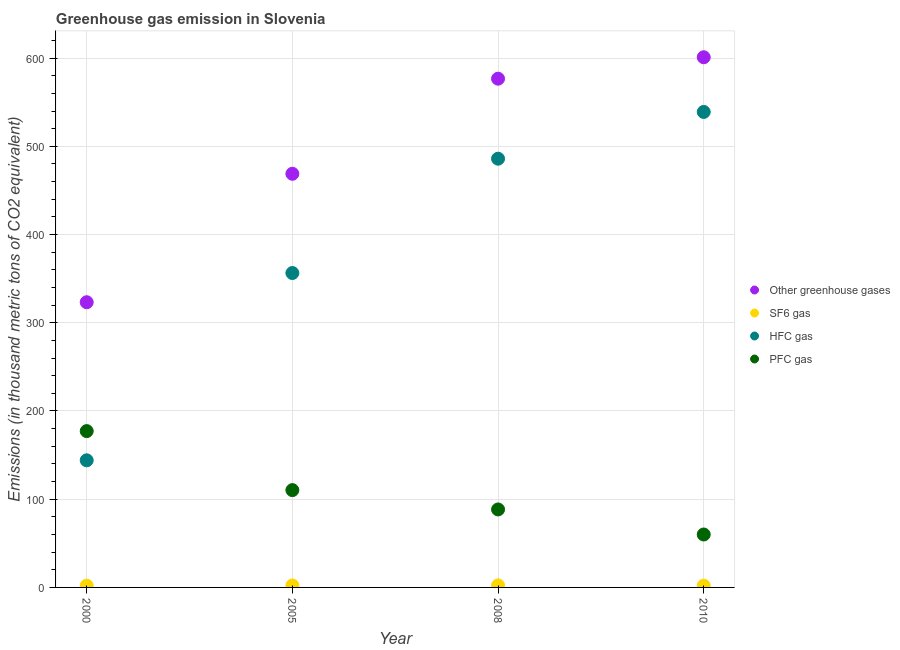What is the emission of pfc gas in 2008?
Your answer should be compact. 88.4. Across all years, what is the maximum emission of pfc gas?
Your answer should be very brief. 177.2. Across all years, what is the minimum emission of pfc gas?
Keep it short and to the point. 60. In which year was the emission of greenhouse gases minimum?
Provide a succinct answer. 2000. What is the total emission of sf6 gas in the graph?
Provide a succinct answer. 8.5. What is the difference between the emission of greenhouse gases in 2000 and that in 2008?
Your answer should be compact. -253.4. What is the difference between the emission of greenhouse gases in 2010 and the emission of hfc gas in 2005?
Ensure brevity in your answer.  244.6. What is the average emission of sf6 gas per year?
Your response must be concise. 2.12. In the year 2008, what is the difference between the emission of hfc gas and emission of sf6 gas?
Give a very brief answer. 483.7. What is the ratio of the emission of sf6 gas in 2005 to that in 2010?
Provide a short and direct response. 1.1. Is the emission of hfc gas in 2000 less than that in 2005?
Offer a very short reply. Yes. Is the difference between the emission of greenhouse gases in 2000 and 2010 greater than the difference between the emission of pfc gas in 2000 and 2010?
Provide a succinct answer. No. What is the difference between the highest and the second highest emission of sf6 gas?
Your answer should be compact. 0.1. What is the difference between the highest and the lowest emission of greenhouse gases?
Your answer should be very brief. 277.7. In how many years, is the emission of pfc gas greater than the average emission of pfc gas taken over all years?
Offer a terse response. 2. Is it the case that in every year, the sum of the emission of greenhouse gases and emission of sf6 gas is greater than the emission of hfc gas?
Make the answer very short. Yes. Is the emission of sf6 gas strictly greater than the emission of greenhouse gases over the years?
Keep it short and to the point. No. Is the emission of greenhouse gases strictly less than the emission of pfc gas over the years?
Your answer should be compact. No. What is the difference between two consecutive major ticks on the Y-axis?
Your response must be concise. 100. Does the graph contain any zero values?
Offer a terse response. No. Does the graph contain grids?
Give a very brief answer. Yes. What is the title of the graph?
Your answer should be compact. Greenhouse gas emission in Slovenia. What is the label or title of the Y-axis?
Your answer should be very brief. Emissions (in thousand metric tons of CO2 equivalent). What is the Emissions (in thousand metric tons of CO2 equivalent) in Other greenhouse gases in 2000?
Provide a succinct answer. 323.3. What is the Emissions (in thousand metric tons of CO2 equivalent) of SF6 gas in 2000?
Give a very brief answer. 2. What is the Emissions (in thousand metric tons of CO2 equivalent) of HFC gas in 2000?
Offer a very short reply. 144.1. What is the Emissions (in thousand metric tons of CO2 equivalent) in PFC gas in 2000?
Ensure brevity in your answer.  177.2. What is the Emissions (in thousand metric tons of CO2 equivalent) in Other greenhouse gases in 2005?
Offer a terse response. 468.9. What is the Emissions (in thousand metric tons of CO2 equivalent) of SF6 gas in 2005?
Provide a short and direct response. 2.2. What is the Emissions (in thousand metric tons of CO2 equivalent) of HFC gas in 2005?
Your response must be concise. 356.4. What is the Emissions (in thousand metric tons of CO2 equivalent) in PFC gas in 2005?
Your response must be concise. 110.3. What is the Emissions (in thousand metric tons of CO2 equivalent) in Other greenhouse gases in 2008?
Offer a very short reply. 576.7. What is the Emissions (in thousand metric tons of CO2 equivalent) of HFC gas in 2008?
Make the answer very short. 486. What is the Emissions (in thousand metric tons of CO2 equivalent) in PFC gas in 2008?
Make the answer very short. 88.4. What is the Emissions (in thousand metric tons of CO2 equivalent) in Other greenhouse gases in 2010?
Provide a short and direct response. 601. What is the Emissions (in thousand metric tons of CO2 equivalent) of SF6 gas in 2010?
Your answer should be compact. 2. What is the Emissions (in thousand metric tons of CO2 equivalent) of HFC gas in 2010?
Your answer should be very brief. 539. What is the Emissions (in thousand metric tons of CO2 equivalent) of PFC gas in 2010?
Provide a short and direct response. 60. Across all years, what is the maximum Emissions (in thousand metric tons of CO2 equivalent) of Other greenhouse gases?
Your answer should be very brief. 601. Across all years, what is the maximum Emissions (in thousand metric tons of CO2 equivalent) in HFC gas?
Your answer should be very brief. 539. Across all years, what is the maximum Emissions (in thousand metric tons of CO2 equivalent) in PFC gas?
Provide a succinct answer. 177.2. Across all years, what is the minimum Emissions (in thousand metric tons of CO2 equivalent) in Other greenhouse gases?
Make the answer very short. 323.3. Across all years, what is the minimum Emissions (in thousand metric tons of CO2 equivalent) in HFC gas?
Provide a short and direct response. 144.1. Across all years, what is the minimum Emissions (in thousand metric tons of CO2 equivalent) in PFC gas?
Give a very brief answer. 60. What is the total Emissions (in thousand metric tons of CO2 equivalent) in Other greenhouse gases in the graph?
Your response must be concise. 1969.9. What is the total Emissions (in thousand metric tons of CO2 equivalent) of SF6 gas in the graph?
Your answer should be compact. 8.5. What is the total Emissions (in thousand metric tons of CO2 equivalent) in HFC gas in the graph?
Your answer should be compact. 1525.5. What is the total Emissions (in thousand metric tons of CO2 equivalent) of PFC gas in the graph?
Ensure brevity in your answer.  435.9. What is the difference between the Emissions (in thousand metric tons of CO2 equivalent) of Other greenhouse gases in 2000 and that in 2005?
Your answer should be compact. -145.6. What is the difference between the Emissions (in thousand metric tons of CO2 equivalent) in HFC gas in 2000 and that in 2005?
Offer a terse response. -212.3. What is the difference between the Emissions (in thousand metric tons of CO2 equivalent) of PFC gas in 2000 and that in 2005?
Offer a very short reply. 66.9. What is the difference between the Emissions (in thousand metric tons of CO2 equivalent) of Other greenhouse gases in 2000 and that in 2008?
Ensure brevity in your answer.  -253.4. What is the difference between the Emissions (in thousand metric tons of CO2 equivalent) in HFC gas in 2000 and that in 2008?
Give a very brief answer. -341.9. What is the difference between the Emissions (in thousand metric tons of CO2 equivalent) of PFC gas in 2000 and that in 2008?
Provide a short and direct response. 88.8. What is the difference between the Emissions (in thousand metric tons of CO2 equivalent) in Other greenhouse gases in 2000 and that in 2010?
Give a very brief answer. -277.7. What is the difference between the Emissions (in thousand metric tons of CO2 equivalent) in SF6 gas in 2000 and that in 2010?
Provide a succinct answer. 0. What is the difference between the Emissions (in thousand metric tons of CO2 equivalent) in HFC gas in 2000 and that in 2010?
Give a very brief answer. -394.9. What is the difference between the Emissions (in thousand metric tons of CO2 equivalent) in PFC gas in 2000 and that in 2010?
Make the answer very short. 117.2. What is the difference between the Emissions (in thousand metric tons of CO2 equivalent) in Other greenhouse gases in 2005 and that in 2008?
Make the answer very short. -107.8. What is the difference between the Emissions (in thousand metric tons of CO2 equivalent) of HFC gas in 2005 and that in 2008?
Provide a succinct answer. -129.6. What is the difference between the Emissions (in thousand metric tons of CO2 equivalent) of PFC gas in 2005 and that in 2008?
Keep it short and to the point. 21.9. What is the difference between the Emissions (in thousand metric tons of CO2 equivalent) in Other greenhouse gases in 2005 and that in 2010?
Make the answer very short. -132.1. What is the difference between the Emissions (in thousand metric tons of CO2 equivalent) of HFC gas in 2005 and that in 2010?
Provide a short and direct response. -182.6. What is the difference between the Emissions (in thousand metric tons of CO2 equivalent) in PFC gas in 2005 and that in 2010?
Provide a succinct answer. 50.3. What is the difference between the Emissions (in thousand metric tons of CO2 equivalent) in Other greenhouse gases in 2008 and that in 2010?
Keep it short and to the point. -24.3. What is the difference between the Emissions (in thousand metric tons of CO2 equivalent) in SF6 gas in 2008 and that in 2010?
Your answer should be compact. 0.3. What is the difference between the Emissions (in thousand metric tons of CO2 equivalent) of HFC gas in 2008 and that in 2010?
Your response must be concise. -53. What is the difference between the Emissions (in thousand metric tons of CO2 equivalent) of PFC gas in 2008 and that in 2010?
Offer a very short reply. 28.4. What is the difference between the Emissions (in thousand metric tons of CO2 equivalent) in Other greenhouse gases in 2000 and the Emissions (in thousand metric tons of CO2 equivalent) in SF6 gas in 2005?
Offer a terse response. 321.1. What is the difference between the Emissions (in thousand metric tons of CO2 equivalent) in Other greenhouse gases in 2000 and the Emissions (in thousand metric tons of CO2 equivalent) in HFC gas in 2005?
Your answer should be very brief. -33.1. What is the difference between the Emissions (in thousand metric tons of CO2 equivalent) in Other greenhouse gases in 2000 and the Emissions (in thousand metric tons of CO2 equivalent) in PFC gas in 2005?
Provide a succinct answer. 213. What is the difference between the Emissions (in thousand metric tons of CO2 equivalent) in SF6 gas in 2000 and the Emissions (in thousand metric tons of CO2 equivalent) in HFC gas in 2005?
Ensure brevity in your answer.  -354.4. What is the difference between the Emissions (in thousand metric tons of CO2 equivalent) in SF6 gas in 2000 and the Emissions (in thousand metric tons of CO2 equivalent) in PFC gas in 2005?
Make the answer very short. -108.3. What is the difference between the Emissions (in thousand metric tons of CO2 equivalent) of HFC gas in 2000 and the Emissions (in thousand metric tons of CO2 equivalent) of PFC gas in 2005?
Give a very brief answer. 33.8. What is the difference between the Emissions (in thousand metric tons of CO2 equivalent) of Other greenhouse gases in 2000 and the Emissions (in thousand metric tons of CO2 equivalent) of SF6 gas in 2008?
Your answer should be very brief. 321. What is the difference between the Emissions (in thousand metric tons of CO2 equivalent) in Other greenhouse gases in 2000 and the Emissions (in thousand metric tons of CO2 equivalent) in HFC gas in 2008?
Offer a very short reply. -162.7. What is the difference between the Emissions (in thousand metric tons of CO2 equivalent) in Other greenhouse gases in 2000 and the Emissions (in thousand metric tons of CO2 equivalent) in PFC gas in 2008?
Give a very brief answer. 234.9. What is the difference between the Emissions (in thousand metric tons of CO2 equivalent) in SF6 gas in 2000 and the Emissions (in thousand metric tons of CO2 equivalent) in HFC gas in 2008?
Your answer should be very brief. -484. What is the difference between the Emissions (in thousand metric tons of CO2 equivalent) in SF6 gas in 2000 and the Emissions (in thousand metric tons of CO2 equivalent) in PFC gas in 2008?
Offer a terse response. -86.4. What is the difference between the Emissions (in thousand metric tons of CO2 equivalent) in HFC gas in 2000 and the Emissions (in thousand metric tons of CO2 equivalent) in PFC gas in 2008?
Your response must be concise. 55.7. What is the difference between the Emissions (in thousand metric tons of CO2 equivalent) in Other greenhouse gases in 2000 and the Emissions (in thousand metric tons of CO2 equivalent) in SF6 gas in 2010?
Make the answer very short. 321.3. What is the difference between the Emissions (in thousand metric tons of CO2 equivalent) in Other greenhouse gases in 2000 and the Emissions (in thousand metric tons of CO2 equivalent) in HFC gas in 2010?
Provide a short and direct response. -215.7. What is the difference between the Emissions (in thousand metric tons of CO2 equivalent) in Other greenhouse gases in 2000 and the Emissions (in thousand metric tons of CO2 equivalent) in PFC gas in 2010?
Provide a short and direct response. 263.3. What is the difference between the Emissions (in thousand metric tons of CO2 equivalent) of SF6 gas in 2000 and the Emissions (in thousand metric tons of CO2 equivalent) of HFC gas in 2010?
Offer a terse response. -537. What is the difference between the Emissions (in thousand metric tons of CO2 equivalent) of SF6 gas in 2000 and the Emissions (in thousand metric tons of CO2 equivalent) of PFC gas in 2010?
Your response must be concise. -58. What is the difference between the Emissions (in thousand metric tons of CO2 equivalent) in HFC gas in 2000 and the Emissions (in thousand metric tons of CO2 equivalent) in PFC gas in 2010?
Make the answer very short. 84.1. What is the difference between the Emissions (in thousand metric tons of CO2 equivalent) of Other greenhouse gases in 2005 and the Emissions (in thousand metric tons of CO2 equivalent) of SF6 gas in 2008?
Your answer should be very brief. 466.6. What is the difference between the Emissions (in thousand metric tons of CO2 equivalent) of Other greenhouse gases in 2005 and the Emissions (in thousand metric tons of CO2 equivalent) of HFC gas in 2008?
Make the answer very short. -17.1. What is the difference between the Emissions (in thousand metric tons of CO2 equivalent) of Other greenhouse gases in 2005 and the Emissions (in thousand metric tons of CO2 equivalent) of PFC gas in 2008?
Ensure brevity in your answer.  380.5. What is the difference between the Emissions (in thousand metric tons of CO2 equivalent) in SF6 gas in 2005 and the Emissions (in thousand metric tons of CO2 equivalent) in HFC gas in 2008?
Provide a succinct answer. -483.8. What is the difference between the Emissions (in thousand metric tons of CO2 equivalent) in SF6 gas in 2005 and the Emissions (in thousand metric tons of CO2 equivalent) in PFC gas in 2008?
Your answer should be compact. -86.2. What is the difference between the Emissions (in thousand metric tons of CO2 equivalent) in HFC gas in 2005 and the Emissions (in thousand metric tons of CO2 equivalent) in PFC gas in 2008?
Give a very brief answer. 268. What is the difference between the Emissions (in thousand metric tons of CO2 equivalent) in Other greenhouse gases in 2005 and the Emissions (in thousand metric tons of CO2 equivalent) in SF6 gas in 2010?
Ensure brevity in your answer.  466.9. What is the difference between the Emissions (in thousand metric tons of CO2 equivalent) of Other greenhouse gases in 2005 and the Emissions (in thousand metric tons of CO2 equivalent) of HFC gas in 2010?
Ensure brevity in your answer.  -70.1. What is the difference between the Emissions (in thousand metric tons of CO2 equivalent) in Other greenhouse gases in 2005 and the Emissions (in thousand metric tons of CO2 equivalent) in PFC gas in 2010?
Keep it short and to the point. 408.9. What is the difference between the Emissions (in thousand metric tons of CO2 equivalent) in SF6 gas in 2005 and the Emissions (in thousand metric tons of CO2 equivalent) in HFC gas in 2010?
Ensure brevity in your answer.  -536.8. What is the difference between the Emissions (in thousand metric tons of CO2 equivalent) in SF6 gas in 2005 and the Emissions (in thousand metric tons of CO2 equivalent) in PFC gas in 2010?
Keep it short and to the point. -57.8. What is the difference between the Emissions (in thousand metric tons of CO2 equivalent) in HFC gas in 2005 and the Emissions (in thousand metric tons of CO2 equivalent) in PFC gas in 2010?
Ensure brevity in your answer.  296.4. What is the difference between the Emissions (in thousand metric tons of CO2 equivalent) of Other greenhouse gases in 2008 and the Emissions (in thousand metric tons of CO2 equivalent) of SF6 gas in 2010?
Ensure brevity in your answer.  574.7. What is the difference between the Emissions (in thousand metric tons of CO2 equivalent) of Other greenhouse gases in 2008 and the Emissions (in thousand metric tons of CO2 equivalent) of HFC gas in 2010?
Keep it short and to the point. 37.7. What is the difference between the Emissions (in thousand metric tons of CO2 equivalent) of Other greenhouse gases in 2008 and the Emissions (in thousand metric tons of CO2 equivalent) of PFC gas in 2010?
Provide a short and direct response. 516.7. What is the difference between the Emissions (in thousand metric tons of CO2 equivalent) in SF6 gas in 2008 and the Emissions (in thousand metric tons of CO2 equivalent) in HFC gas in 2010?
Ensure brevity in your answer.  -536.7. What is the difference between the Emissions (in thousand metric tons of CO2 equivalent) of SF6 gas in 2008 and the Emissions (in thousand metric tons of CO2 equivalent) of PFC gas in 2010?
Ensure brevity in your answer.  -57.7. What is the difference between the Emissions (in thousand metric tons of CO2 equivalent) of HFC gas in 2008 and the Emissions (in thousand metric tons of CO2 equivalent) of PFC gas in 2010?
Give a very brief answer. 426. What is the average Emissions (in thousand metric tons of CO2 equivalent) in Other greenhouse gases per year?
Keep it short and to the point. 492.48. What is the average Emissions (in thousand metric tons of CO2 equivalent) in SF6 gas per year?
Offer a very short reply. 2.12. What is the average Emissions (in thousand metric tons of CO2 equivalent) of HFC gas per year?
Your answer should be compact. 381.38. What is the average Emissions (in thousand metric tons of CO2 equivalent) of PFC gas per year?
Keep it short and to the point. 108.97. In the year 2000, what is the difference between the Emissions (in thousand metric tons of CO2 equivalent) of Other greenhouse gases and Emissions (in thousand metric tons of CO2 equivalent) of SF6 gas?
Offer a very short reply. 321.3. In the year 2000, what is the difference between the Emissions (in thousand metric tons of CO2 equivalent) in Other greenhouse gases and Emissions (in thousand metric tons of CO2 equivalent) in HFC gas?
Provide a short and direct response. 179.2. In the year 2000, what is the difference between the Emissions (in thousand metric tons of CO2 equivalent) in Other greenhouse gases and Emissions (in thousand metric tons of CO2 equivalent) in PFC gas?
Provide a succinct answer. 146.1. In the year 2000, what is the difference between the Emissions (in thousand metric tons of CO2 equivalent) of SF6 gas and Emissions (in thousand metric tons of CO2 equivalent) of HFC gas?
Offer a terse response. -142.1. In the year 2000, what is the difference between the Emissions (in thousand metric tons of CO2 equivalent) in SF6 gas and Emissions (in thousand metric tons of CO2 equivalent) in PFC gas?
Keep it short and to the point. -175.2. In the year 2000, what is the difference between the Emissions (in thousand metric tons of CO2 equivalent) in HFC gas and Emissions (in thousand metric tons of CO2 equivalent) in PFC gas?
Your answer should be very brief. -33.1. In the year 2005, what is the difference between the Emissions (in thousand metric tons of CO2 equivalent) in Other greenhouse gases and Emissions (in thousand metric tons of CO2 equivalent) in SF6 gas?
Ensure brevity in your answer.  466.7. In the year 2005, what is the difference between the Emissions (in thousand metric tons of CO2 equivalent) in Other greenhouse gases and Emissions (in thousand metric tons of CO2 equivalent) in HFC gas?
Your answer should be compact. 112.5. In the year 2005, what is the difference between the Emissions (in thousand metric tons of CO2 equivalent) of Other greenhouse gases and Emissions (in thousand metric tons of CO2 equivalent) of PFC gas?
Your answer should be very brief. 358.6. In the year 2005, what is the difference between the Emissions (in thousand metric tons of CO2 equivalent) in SF6 gas and Emissions (in thousand metric tons of CO2 equivalent) in HFC gas?
Make the answer very short. -354.2. In the year 2005, what is the difference between the Emissions (in thousand metric tons of CO2 equivalent) of SF6 gas and Emissions (in thousand metric tons of CO2 equivalent) of PFC gas?
Your answer should be very brief. -108.1. In the year 2005, what is the difference between the Emissions (in thousand metric tons of CO2 equivalent) of HFC gas and Emissions (in thousand metric tons of CO2 equivalent) of PFC gas?
Provide a succinct answer. 246.1. In the year 2008, what is the difference between the Emissions (in thousand metric tons of CO2 equivalent) in Other greenhouse gases and Emissions (in thousand metric tons of CO2 equivalent) in SF6 gas?
Provide a succinct answer. 574.4. In the year 2008, what is the difference between the Emissions (in thousand metric tons of CO2 equivalent) of Other greenhouse gases and Emissions (in thousand metric tons of CO2 equivalent) of HFC gas?
Offer a very short reply. 90.7. In the year 2008, what is the difference between the Emissions (in thousand metric tons of CO2 equivalent) in Other greenhouse gases and Emissions (in thousand metric tons of CO2 equivalent) in PFC gas?
Your answer should be very brief. 488.3. In the year 2008, what is the difference between the Emissions (in thousand metric tons of CO2 equivalent) in SF6 gas and Emissions (in thousand metric tons of CO2 equivalent) in HFC gas?
Give a very brief answer. -483.7. In the year 2008, what is the difference between the Emissions (in thousand metric tons of CO2 equivalent) of SF6 gas and Emissions (in thousand metric tons of CO2 equivalent) of PFC gas?
Ensure brevity in your answer.  -86.1. In the year 2008, what is the difference between the Emissions (in thousand metric tons of CO2 equivalent) in HFC gas and Emissions (in thousand metric tons of CO2 equivalent) in PFC gas?
Make the answer very short. 397.6. In the year 2010, what is the difference between the Emissions (in thousand metric tons of CO2 equivalent) in Other greenhouse gases and Emissions (in thousand metric tons of CO2 equivalent) in SF6 gas?
Keep it short and to the point. 599. In the year 2010, what is the difference between the Emissions (in thousand metric tons of CO2 equivalent) in Other greenhouse gases and Emissions (in thousand metric tons of CO2 equivalent) in HFC gas?
Your response must be concise. 62. In the year 2010, what is the difference between the Emissions (in thousand metric tons of CO2 equivalent) of Other greenhouse gases and Emissions (in thousand metric tons of CO2 equivalent) of PFC gas?
Provide a short and direct response. 541. In the year 2010, what is the difference between the Emissions (in thousand metric tons of CO2 equivalent) in SF6 gas and Emissions (in thousand metric tons of CO2 equivalent) in HFC gas?
Your response must be concise. -537. In the year 2010, what is the difference between the Emissions (in thousand metric tons of CO2 equivalent) in SF6 gas and Emissions (in thousand metric tons of CO2 equivalent) in PFC gas?
Ensure brevity in your answer.  -58. In the year 2010, what is the difference between the Emissions (in thousand metric tons of CO2 equivalent) of HFC gas and Emissions (in thousand metric tons of CO2 equivalent) of PFC gas?
Make the answer very short. 479. What is the ratio of the Emissions (in thousand metric tons of CO2 equivalent) in Other greenhouse gases in 2000 to that in 2005?
Offer a very short reply. 0.69. What is the ratio of the Emissions (in thousand metric tons of CO2 equivalent) in SF6 gas in 2000 to that in 2005?
Your response must be concise. 0.91. What is the ratio of the Emissions (in thousand metric tons of CO2 equivalent) in HFC gas in 2000 to that in 2005?
Provide a succinct answer. 0.4. What is the ratio of the Emissions (in thousand metric tons of CO2 equivalent) of PFC gas in 2000 to that in 2005?
Your answer should be very brief. 1.61. What is the ratio of the Emissions (in thousand metric tons of CO2 equivalent) of Other greenhouse gases in 2000 to that in 2008?
Your answer should be very brief. 0.56. What is the ratio of the Emissions (in thousand metric tons of CO2 equivalent) of SF6 gas in 2000 to that in 2008?
Offer a very short reply. 0.87. What is the ratio of the Emissions (in thousand metric tons of CO2 equivalent) in HFC gas in 2000 to that in 2008?
Give a very brief answer. 0.3. What is the ratio of the Emissions (in thousand metric tons of CO2 equivalent) of PFC gas in 2000 to that in 2008?
Keep it short and to the point. 2. What is the ratio of the Emissions (in thousand metric tons of CO2 equivalent) in Other greenhouse gases in 2000 to that in 2010?
Your answer should be compact. 0.54. What is the ratio of the Emissions (in thousand metric tons of CO2 equivalent) of HFC gas in 2000 to that in 2010?
Give a very brief answer. 0.27. What is the ratio of the Emissions (in thousand metric tons of CO2 equivalent) in PFC gas in 2000 to that in 2010?
Your answer should be very brief. 2.95. What is the ratio of the Emissions (in thousand metric tons of CO2 equivalent) of Other greenhouse gases in 2005 to that in 2008?
Keep it short and to the point. 0.81. What is the ratio of the Emissions (in thousand metric tons of CO2 equivalent) of SF6 gas in 2005 to that in 2008?
Your answer should be compact. 0.96. What is the ratio of the Emissions (in thousand metric tons of CO2 equivalent) of HFC gas in 2005 to that in 2008?
Offer a terse response. 0.73. What is the ratio of the Emissions (in thousand metric tons of CO2 equivalent) in PFC gas in 2005 to that in 2008?
Provide a short and direct response. 1.25. What is the ratio of the Emissions (in thousand metric tons of CO2 equivalent) of Other greenhouse gases in 2005 to that in 2010?
Provide a short and direct response. 0.78. What is the ratio of the Emissions (in thousand metric tons of CO2 equivalent) of SF6 gas in 2005 to that in 2010?
Your response must be concise. 1.1. What is the ratio of the Emissions (in thousand metric tons of CO2 equivalent) of HFC gas in 2005 to that in 2010?
Ensure brevity in your answer.  0.66. What is the ratio of the Emissions (in thousand metric tons of CO2 equivalent) in PFC gas in 2005 to that in 2010?
Your answer should be compact. 1.84. What is the ratio of the Emissions (in thousand metric tons of CO2 equivalent) in Other greenhouse gases in 2008 to that in 2010?
Your response must be concise. 0.96. What is the ratio of the Emissions (in thousand metric tons of CO2 equivalent) in SF6 gas in 2008 to that in 2010?
Your response must be concise. 1.15. What is the ratio of the Emissions (in thousand metric tons of CO2 equivalent) in HFC gas in 2008 to that in 2010?
Offer a very short reply. 0.9. What is the ratio of the Emissions (in thousand metric tons of CO2 equivalent) in PFC gas in 2008 to that in 2010?
Your response must be concise. 1.47. What is the difference between the highest and the second highest Emissions (in thousand metric tons of CO2 equivalent) of Other greenhouse gases?
Your answer should be very brief. 24.3. What is the difference between the highest and the second highest Emissions (in thousand metric tons of CO2 equivalent) of SF6 gas?
Ensure brevity in your answer.  0.1. What is the difference between the highest and the second highest Emissions (in thousand metric tons of CO2 equivalent) of HFC gas?
Make the answer very short. 53. What is the difference between the highest and the second highest Emissions (in thousand metric tons of CO2 equivalent) of PFC gas?
Give a very brief answer. 66.9. What is the difference between the highest and the lowest Emissions (in thousand metric tons of CO2 equivalent) in Other greenhouse gases?
Provide a short and direct response. 277.7. What is the difference between the highest and the lowest Emissions (in thousand metric tons of CO2 equivalent) of SF6 gas?
Offer a terse response. 0.3. What is the difference between the highest and the lowest Emissions (in thousand metric tons of CO2 equivalent) in HFC gas?
Provide a succinct answer. 394.9. What is the difference between the highest and the lowest Emissions (in thousand metric tons of CO2 equivalent) of PFC gas?
Provide a succinct answer. 117.2. 